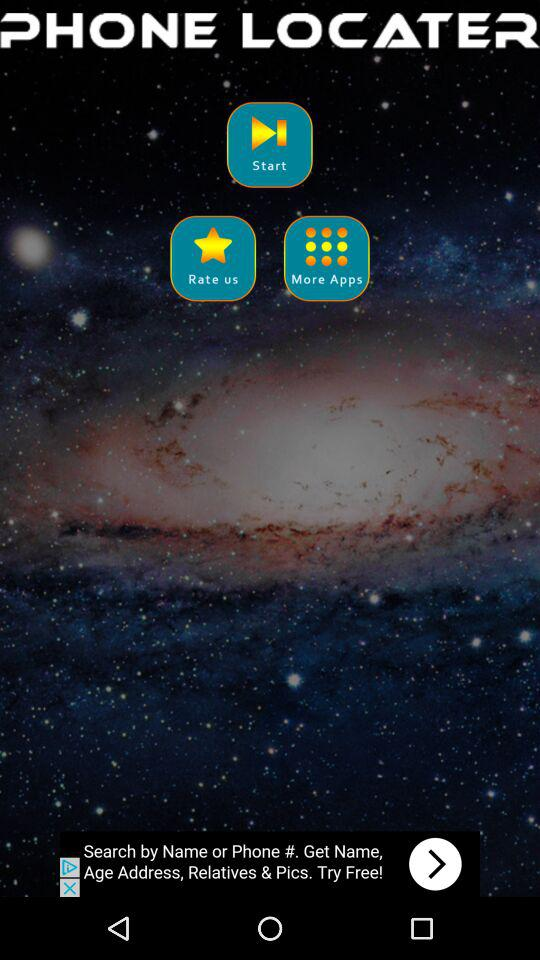What is the application name? The application name is "PHONE LOCATER". 